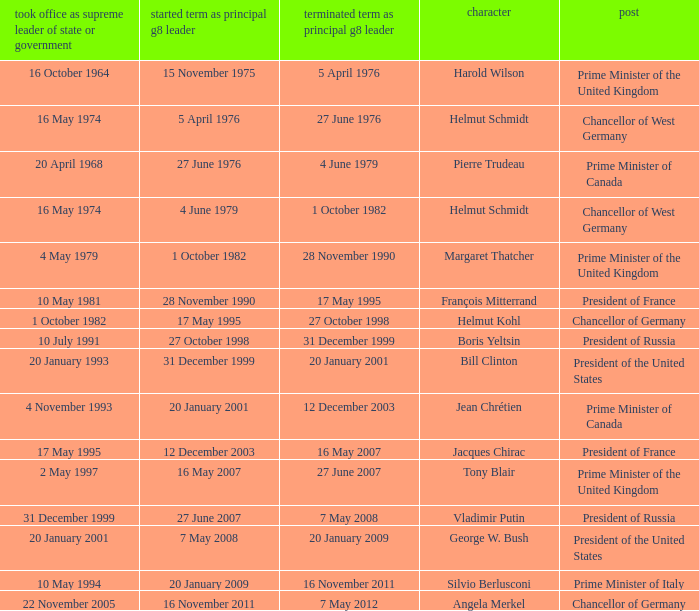When did the Prime Minister of Italy take office? 10 May 1994. 